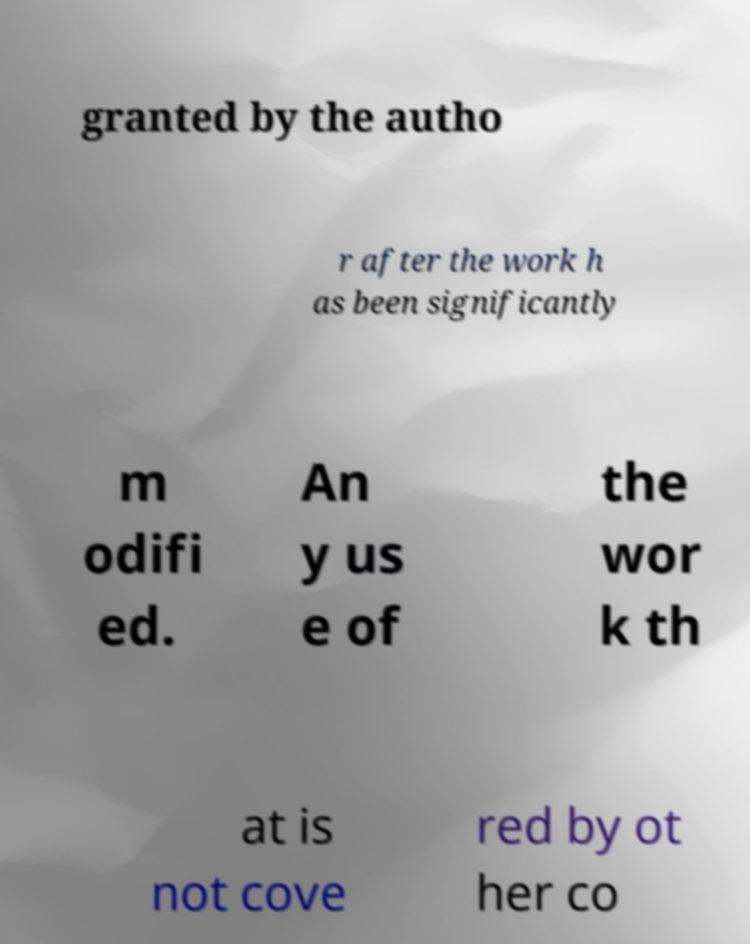Please read and relay the text visible in this image. What does it say? granted by the autho r after the work h as been significantly m odifi ed. An y us e of the wor k th at is not cove red by ot her co 